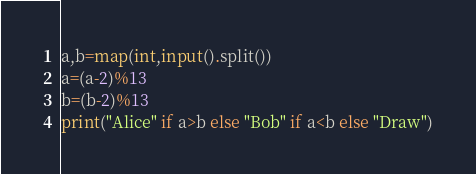Convert code to text. <code><loc_0><loc_0><loc_500><loc_500><_Python_>a,b=map(int,input().split())
a=(a-2)%13
b=(b-2)%13
print("Alice" if a>b else "Bob" if a<b else "Draw")</code> 